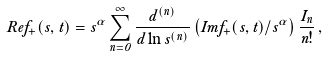Convert formula to latex. <formula><loc_0><loc_0><loc_500><loc_500>R e f _ { + } ( s , t ) = s ^ { \alpha } \sum _ { n = 0 } ^ { \infty } \frac { d ^ { ( n ) } } { d \ln s ^ { ( n ) } } \left ( I m f _ { + } ( s , t ) / s ^ { \alpha } \right ) \frac { I _ { n } } { n ! } \, ,</formula> 